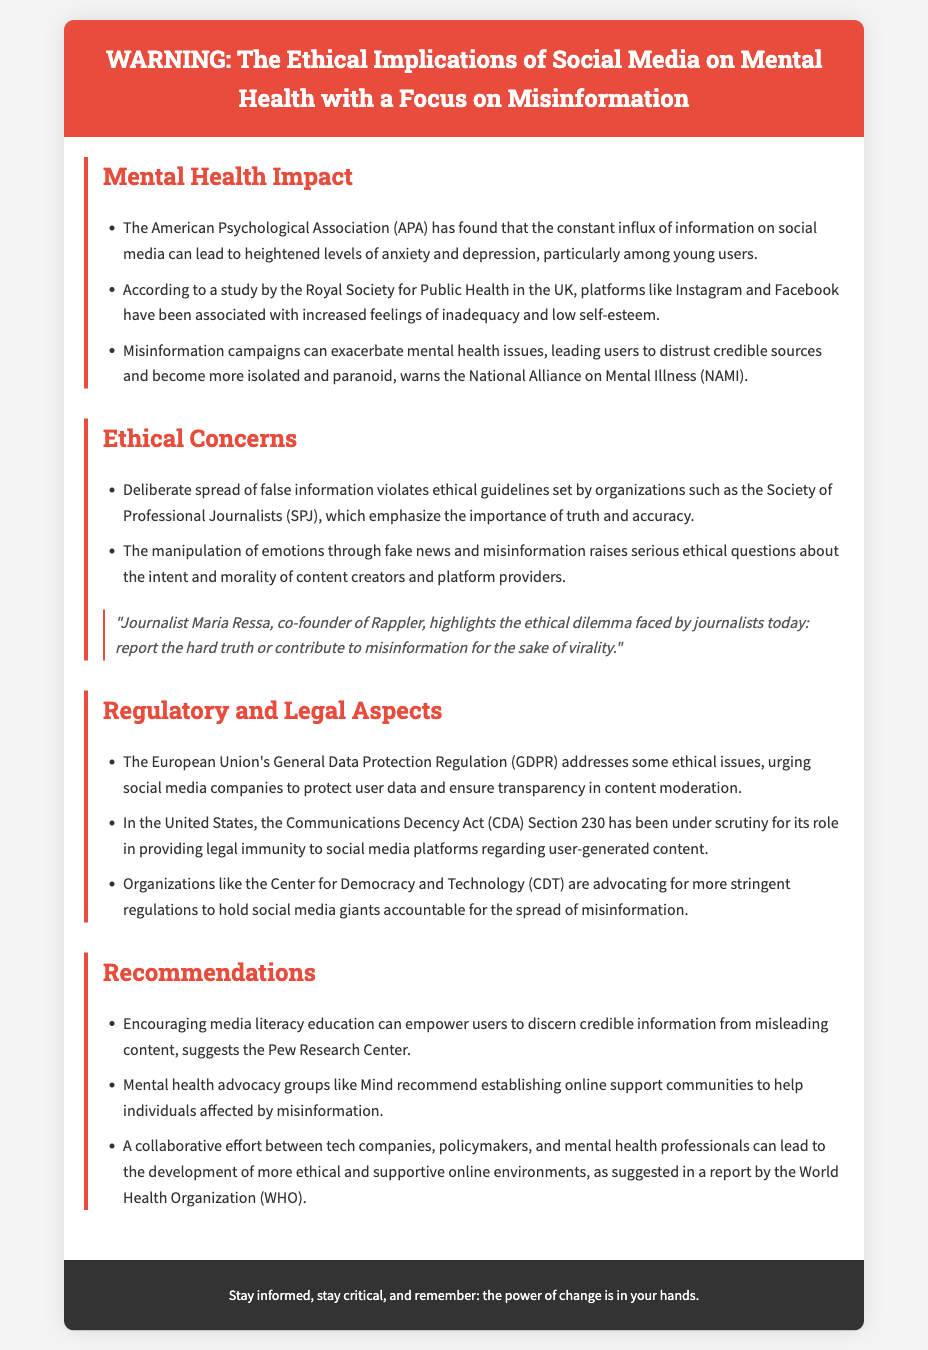What organization found that social media can lead to heightened anxiety? The document states that the American Psychological Association (APA) found the connection between social media and anxiety.
Answer: American Psychological Association (APA) What negative feelings are associated with Instagram and Facebook? The document mentions that platforms like Instagram and Facebook are associated with increased feelings of inadequacy and low self-esteem.
Answer: Feelings of inadequacy and low self-esteem Which ethical guidelines does the Society of Professional Journalists emphasize? The document notes that the Society of Professional Journalists emphasizes the importance of truth and accuracy.
Answer: Truth and accuracy What regulatory aspect is addressed by the European Union related to social media? The document refers to the General Data Protection Regulation (GDPR) in the context of ethical issues and user data protection.
Answer: General Data Protection Regulation (GDPR) What is one recommendation for combating misinformation? The document recommends encouraging media literacy education as a way to empower users against misinformation.
Answer: Encouraging media literacy education How many ethical concerns are listed in the document? The document lists two ethical concerns regarding the spread of misinformation and the manipulation of emotions.
Answer: Two What powerful idea does journalist Maria Ressa highlight? The document quotes Maria Ressa highlighting the ethical dilemma of reporting hard truths versus contributing to misinformation for virality.
Answer: Ethical dilemma of reporting hard truths What organization is advocating for more stringent regulations on social media? The document mentions the Center for Democracy and Technology (CDT) as an organization advocating for more regulations.
Answer: Center for Democracy and Technology (CDT) 